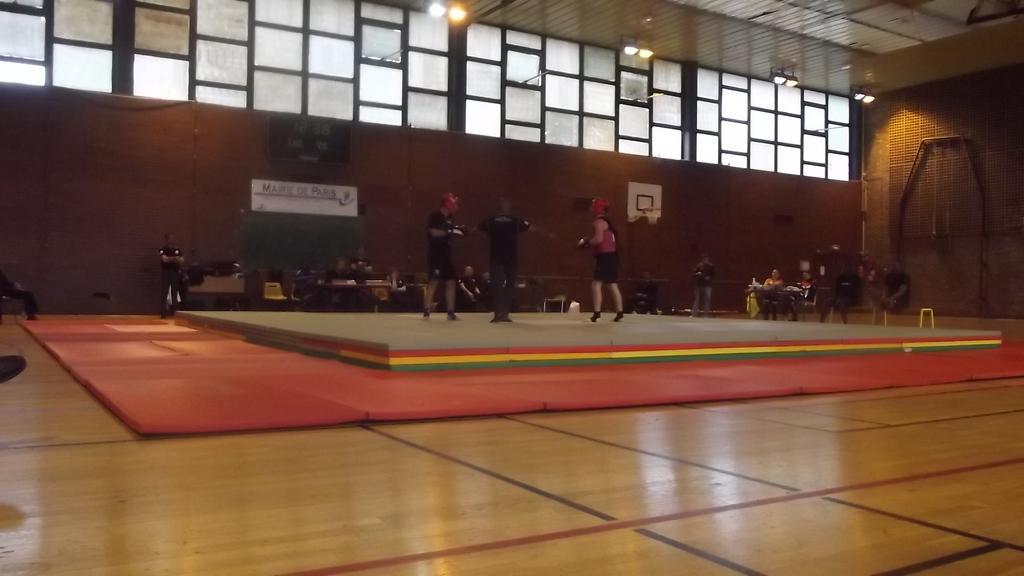Can you describe this image briefly? In this picture I can see there are three people standing here and there are few other people in the backdrop and the people on the dais are wearing gloves and helmets. There are few windows and there are lights attached to the ceiling. 